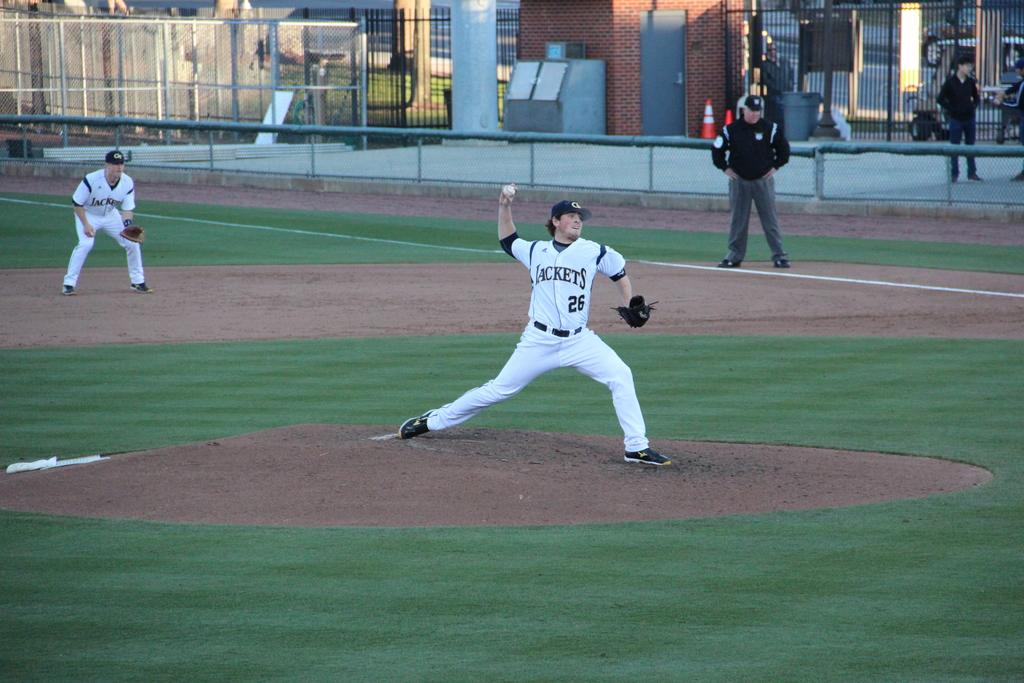How many people are present in the image? There are three people in the image. What are the people in the image doing? The people are standing in the image. What can be seen in the background of the image? There is a fence and a road in the background of the image. What is the person in the image wishing for? There is no indication of the person's wishes in the image, as it only shows them standing. What thought is the person in the image having? The image does not provide any information about the person's thoughts, as it only shows them standing. 